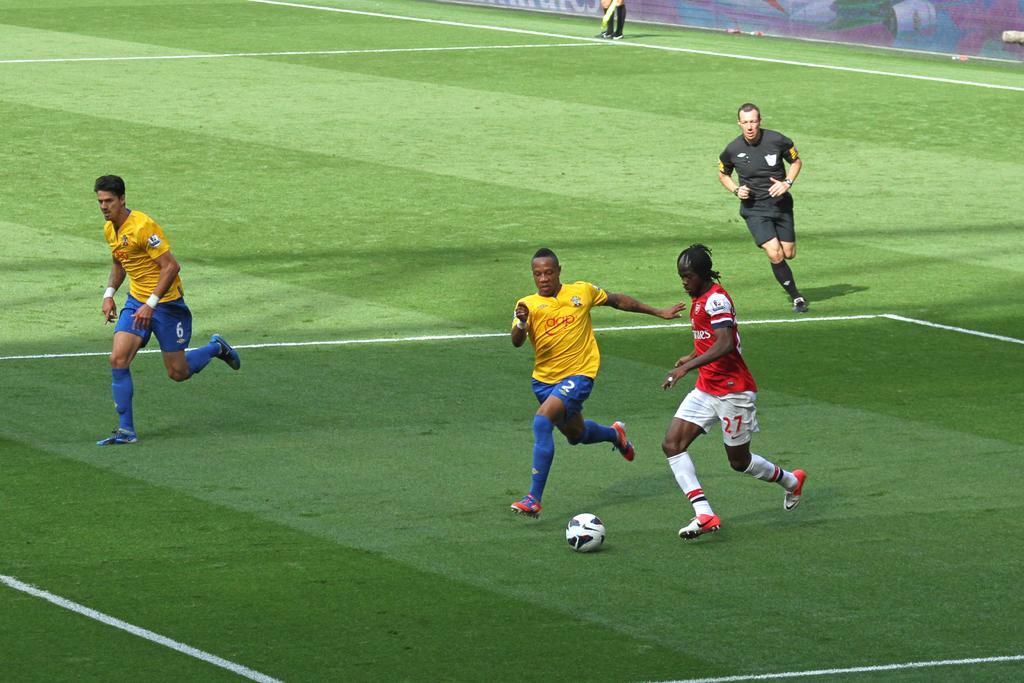Describe this image in one or two sentences. In this image I can see a football ground and on it I can see few white lines and five persons are standing. I can also see a white colour football in the front. 